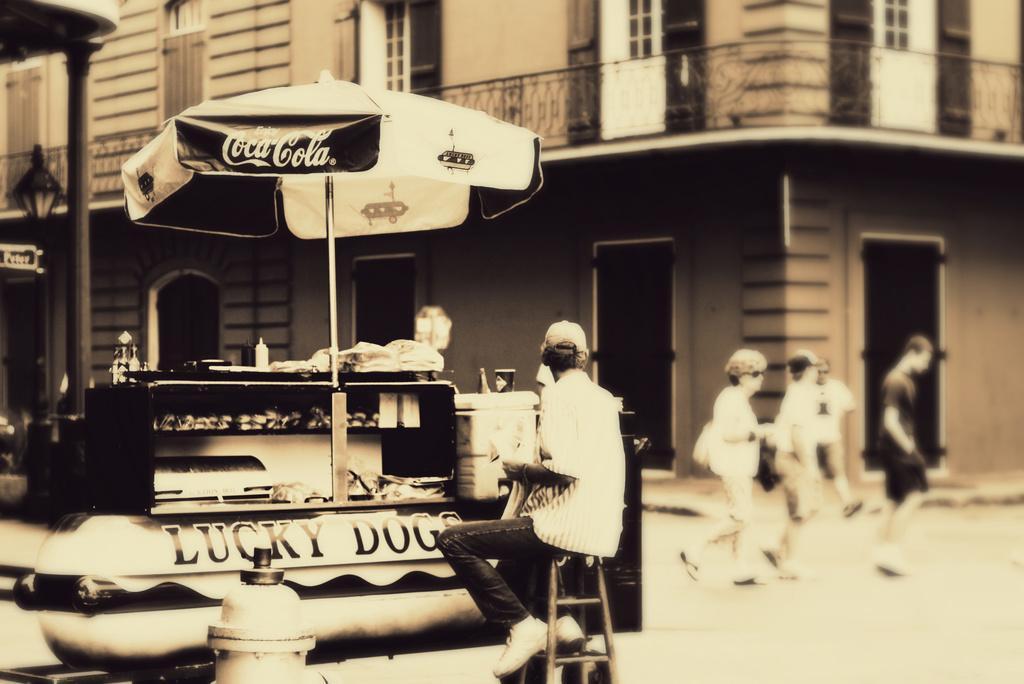In one or two sentences, can you explain what this image depicts? In this picture there is a person sitting on a chair and few people walking on the road. We can see stall, umbrella, light and pole. In the background of the image we can see building and railing. 